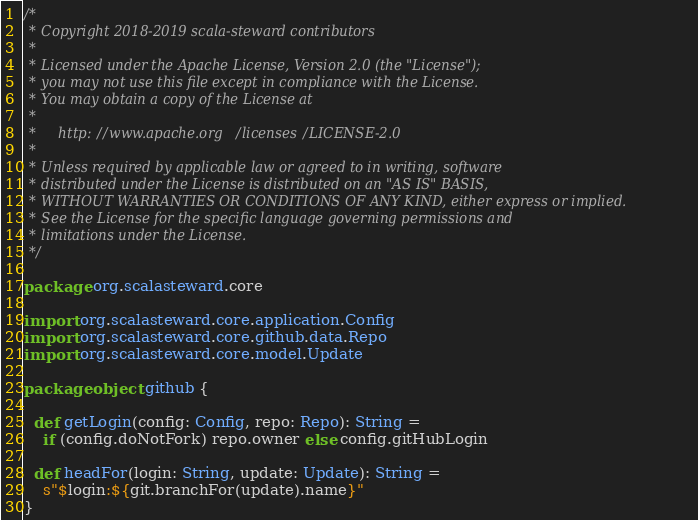<code> <loc_0><loc_0><loc_500><loc_500><_Scala_>/*
 * Copyright 2018-2019 scala-steward contributors
 *
 * Licensed under the Apache License, Version 2.0 (the "License");
 * you may not use this file except in compliance with the License.
 * You may obtain a copy of the License at
 *
 *     http://www.apache.org/licenses/LICENSE-2.0
 *
 * Unless required by applicable law or agreed to in writing, software
 * distributed under the License is distributed on an "AS IS" BASIS,
 * WITHOUT WARRANTIES OR CONDITIONS OF ANY KIND, either express or implied.
 * See the License for the specific language governing permissions and
 * limitations under the License.
 */

package org.scalasteward.core

import org.scalasteward.core.application.Config
import org.scalasteward.core.github.data.Repo
import org.scalasteward.core.model.Update

package object github {

  def getLogin(config: Config, repo: Repo): String =
    if (config.doNotFork) repo.owner else config.gitHubLogin

  def headFor(login: String, update: Update): String =
    s"$login:${git.branchFor(update).name}"
}
</code> 